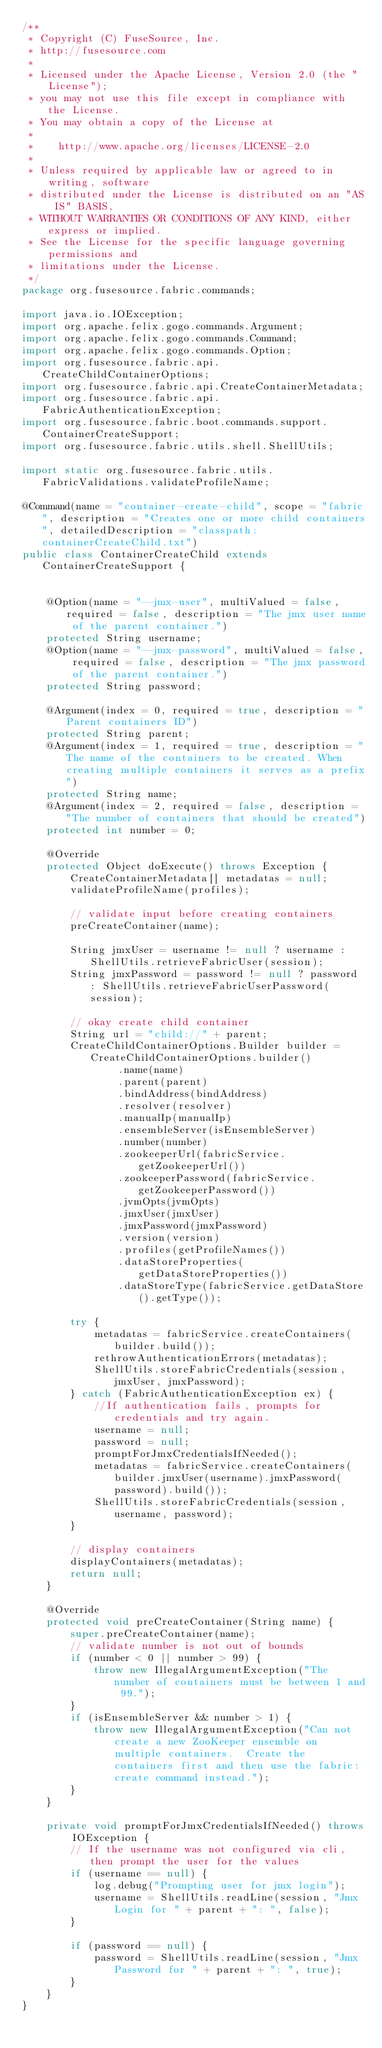Convert code to text. <code><loc_0><loc_0><loc_500><loc_500><_Java_>/**
 * Copyright (C) FuseSource, Inc.
 * http://fusesource.com
 *
 * Licensed under the Apache License, Version 2.0 (the "License");
 * you may not use this file except in compliance with the License.
 * You may obtain a copy of the License at
 *
 *    http://www.apache.org/licenses/LICENSE-2.0
 *
 * Unless required by applicable law or agreed to in writing, software
 * distributed under the License is distributed on an "AS IS" BASIS,
 * WITHOUT WARRANTIES OR CONDITIONS OF ANY KIND, either express or implied.
 * See the License for the specific language governing permissions and
 * limitations under the License.
 */
package org.fusesource.fabric.commands;

import java.io.IOException;
import org.apache.felix.gogo.commands.Argument;
import org.apache.felix.gogo.commands.Command;
import org.apache.felix.gogo.commands.Option;
import org.fusesource.fabric.api.CreateChildContainerOptions;
import org.fusesource.fabric.api.CreateContainerMetadata;
import org.fusesource.fabric.api.FabricAuthenticationException;
import org.fusesource.fabric.boot.commands.support.ContainerCreateSupport;
import org.fusesource.fabric.utils.shell.ShellUtils;

import static org.fusesource.fabric.utils.FabricValidations.validateProfileName;

@Command(name = "container-create-child", scope = "fabric", description = "Creates one or more child containers", detailedDescription = "classpath:containerCreateChild.txt")
public class ContainerCreateChild extends ContainerCreateSupport {


    @Option(name = "--jmx-user", multiValued = false, required = false, description = "The jmx user name of the parent container.")
    protected String username;
    @Option(name = "--jmx-password", multiValued = false, required = false, description = "The jmx password of the parent container.")
    protected String password;

    @Argument(index = 0, required = true, description = "Parent containers ID")
    protected String parent;
    @Argument(index = 1, required = true, description = "The name of the containers to be created. When creating multiple containers it serves as a prefix")
    protected String name;
    @Argument(index = 2, required = false, description = "The number of containers that should be created")
    protected int number = 0;

    @Override
    protected Object doExecute() throws Exception {
        CreateContainerMetadata[] metadatas = null;
        validateProfileName(profiles);

        // validate input before creating containers
        preCreateContainer(name);

        String jmxUser = username != null ? username : ShellUtils.retrieveFabricUser(session);
        String jmxPassword = password != null ? password : ShellUtils.retrieveFabricUserPassword(session);

        // okay create child container
        String url = "child://" + parent;
        CreateChildContainerOptions.Builder builder = CreateChildContainerOptions.builder()
                .name(name)
                .parent(parent)
                .bindAddress(bindAddress)
                .resolver(resolver)
                .manualIp(manualIp)
                .ensembleServer(isEnsembleServer)
                .number(number)
                .zookeeperUrl(fabricService.getZookeeperUrl())
                .zookeeperPassword(fabricService.getZookeeperPassword())
                .jvmOpts(jvmOpts)
                .jmxUser(jmxUser)
                .jmxPassword(jmxPassword)
                .version(version)
                .profiles(getProfileNames())
                .dataStoreProperties(getDataStoreProperties())
                .dataStoreType(fabricService.getDataStore().getType());

        try {
            metadatas = fabricService.createContainers(builder.build());
            rethrowAuthenticationErrors(metadatas);
            ShellUtils.storeFabricCredentials(session, jmxUser, jmxPassword);
        } catch (FabricAuthenticationException ex) {
            //If authentication fails, prompts for credentials and try again.
            username = null;
            password = null;
            promptForJmxCredentialsIfNeeded();
            metadatas = fabricService.createContainers(builder.jmxUser(username).jmxPassword(password).build());
            ShellUtils.storeFabricCredentials(session, username, password);
        }

        // display containers
        displayContainers(metadatas);
        return null;
    }

    @Override
    protected void preCreateContainer(String name) {
        super.preCreateContainer(name);
        // validate number is not out of bounds
        if (number < 0 || number > 99) {
            throw new IllegalArgumentException("The number of containers must be between 1 and 99.");
        }
        if (isEnsembleServer && number > 1) {
            throw new IllegalArgumentException("Can not create a new ZooKeeper ensemble on multiple containers.  Create the containers first and then use the fabric:create command instead.");
        }
    }

    private void promptForJmxCredentialsIfNeeded() throws IOException {
        // If the username was not configured via cli, then prompt the user for the values
        if (username == null) {
            log.debug("Prompting user for jmx login");
            username = ShellUtils.readLine(session, "Jmx Login for " + parent + ": ", false);
        }

        if (password == null) {
            password = ShellUtils.readLine(session, "Jmx Password for " + parent + ": ", true);
        }
    }
}
</code> 